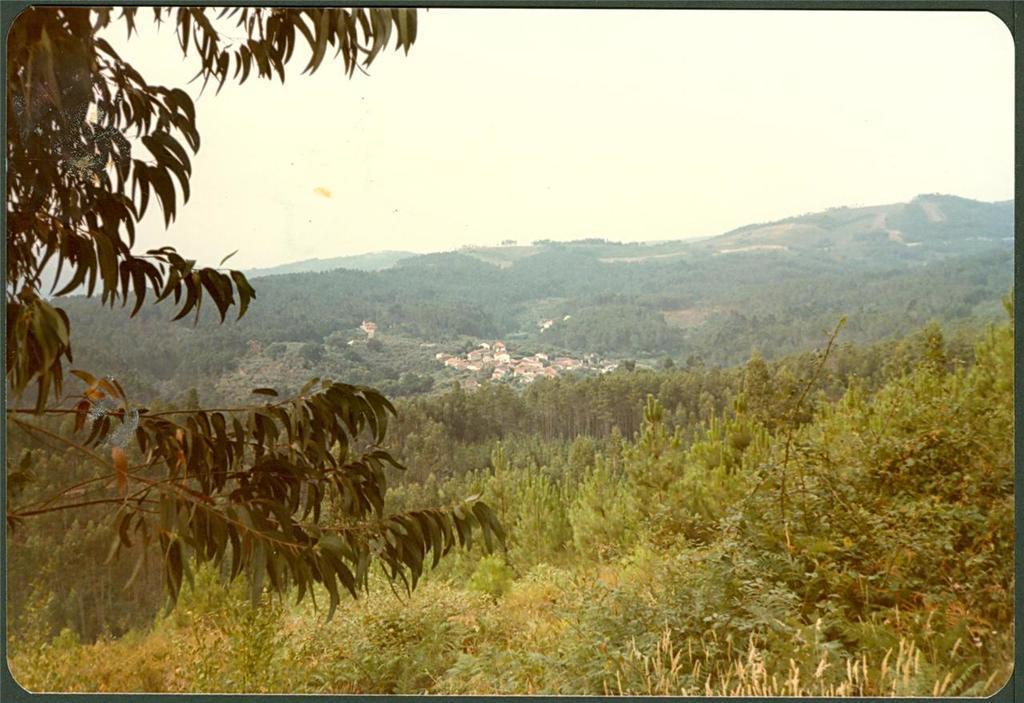How would you summarize this image in a sentence or two? As we can see in the image there are trees and buildings. At the top there is sky. 